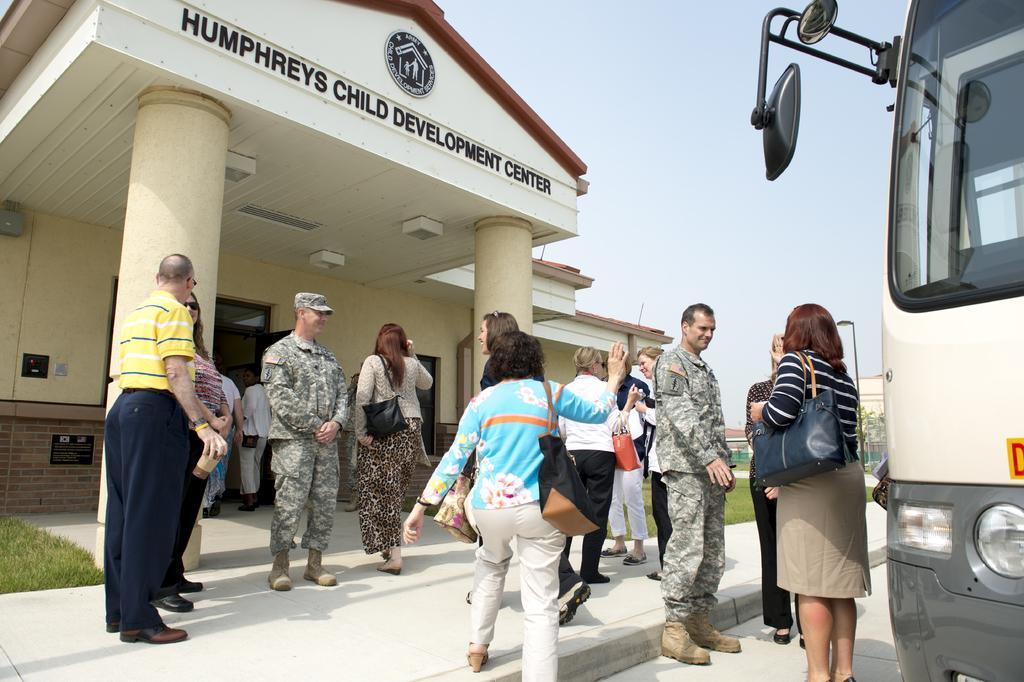Describe this image in one or two sentences. This is an outside view. On the right side, I can see a vehicle on the road. On the left side there is a building. Here I can see many people are standing on the ground. In the background, I can see the grass. At the top I can see the sky. 